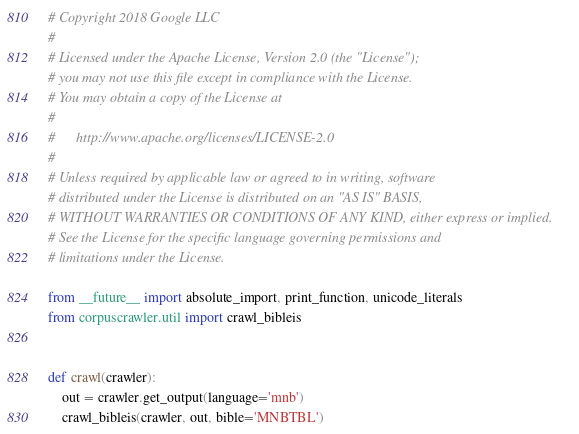<code> <loc_0><loc_0><loc_500><loc_500><_Python_># Copyright 2018 Google LLC
#
# Licensed under the Apache License, Version 2.0 (the "License");
# you may not use this file except in compliance with the License.
# You may obtain a copy of the License at
#
#      http://www.apache.org/licenses/LICENSE-2.0
#
# Unless required by applicable law or agreed to in writing, software
# distributed under the License is distributed on an "AS IS" BASIS,
# WITHOUT WARRANTIES OR CONDITIONS OF ANY KIND, either express or implied.
# See the License for the specific language governing permissions and
# limitations under the License.

from __future__ import absolute_import, print_function, unicode_literals
from corpuscrawler.util import crawl_bibleis


def crawl(crawler):
    out = crawler.get_output(language='mnb')
    crawl_bibleis(crawler, out, bible='MNBTBL')
</code> 